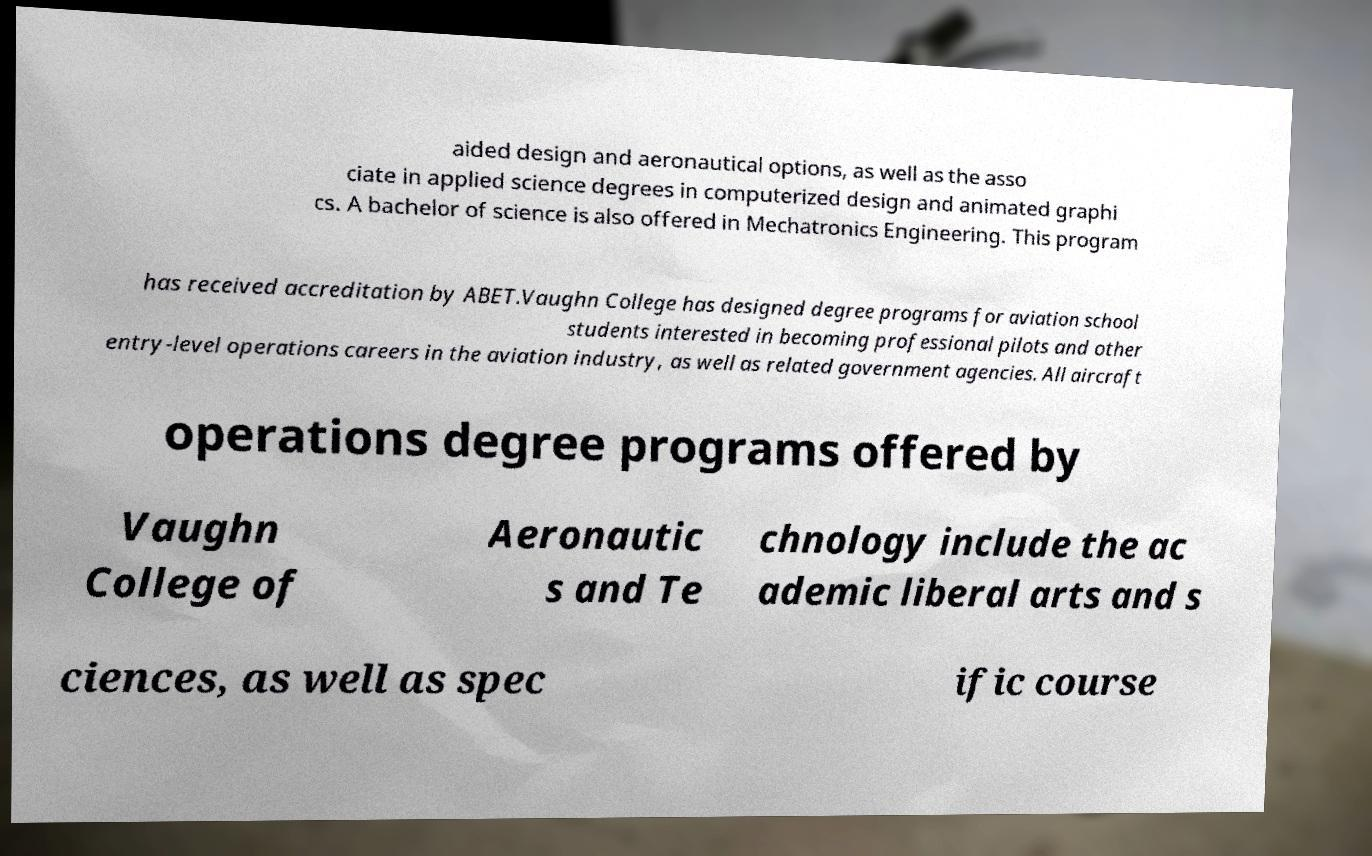For documentation purposes, I need the text within this image transcribed. Could you provide that? aided design and aeronautical options, as well as the asso ciate in applied science degrees in computerized design and animated graphi cs. A bachelor of science is also offered in Mechatronics Engineering. This program has received accreditation by ABET.Vaughn College has designed degree programs for aviation school students interested in becoming professional pilots and other entry-level operations careers in the aviation industry, as well as related government agencies. All aircraft operations degree programs offered by Vaughn College of Aeronautic s and Te chnology include the ac ademic liberal arts and s ciences, as well as spec ific course 